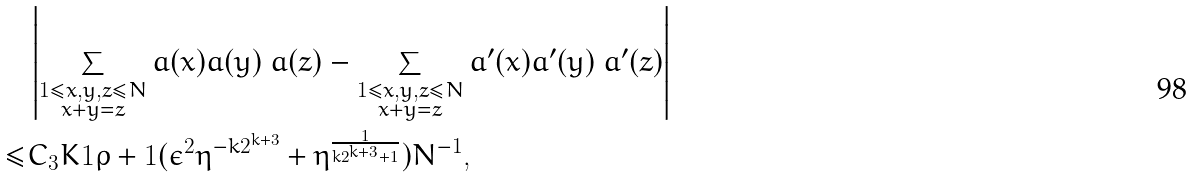Convert formula to latex. <formula><loc_0><loc_0><loc_500><loc_500>& \left | \sum _ { \substack { 1 \leq x , y , z \leq N \\ x + y = z } } a ( x ) a ( y ) \ a ( z ) - \sum _ { \substack { 1 \leq x , y , z \leq N \\ x + y = z } } a ^ { \prime } ( x ) a ^ { \prime } ( y ) \ a ^ { \prime } ( z ) \right | \\ \leq & C _ { 3 } K ^ { } { 1 } { \rho + 1 } ( \epsilon ^ { 2 } \eta ^ { - k 2 ^ { k + 3 } } + \eta ^ { \frac { 1 } { k 2 ^ { k + 3 } + 1 } } ) N ^ { - 1 } ,</formula> 